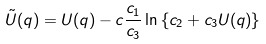<formula> <loc_0><loc_0><loc_500><loc_500>\tilde { U } ( q ) = U ( q ) - c \frac { c _ { 1 } } { c _ { 3 } } \ln \left \{ c _ { 2 } + c _ { 3 } U ( q ) \right \}</formula> 